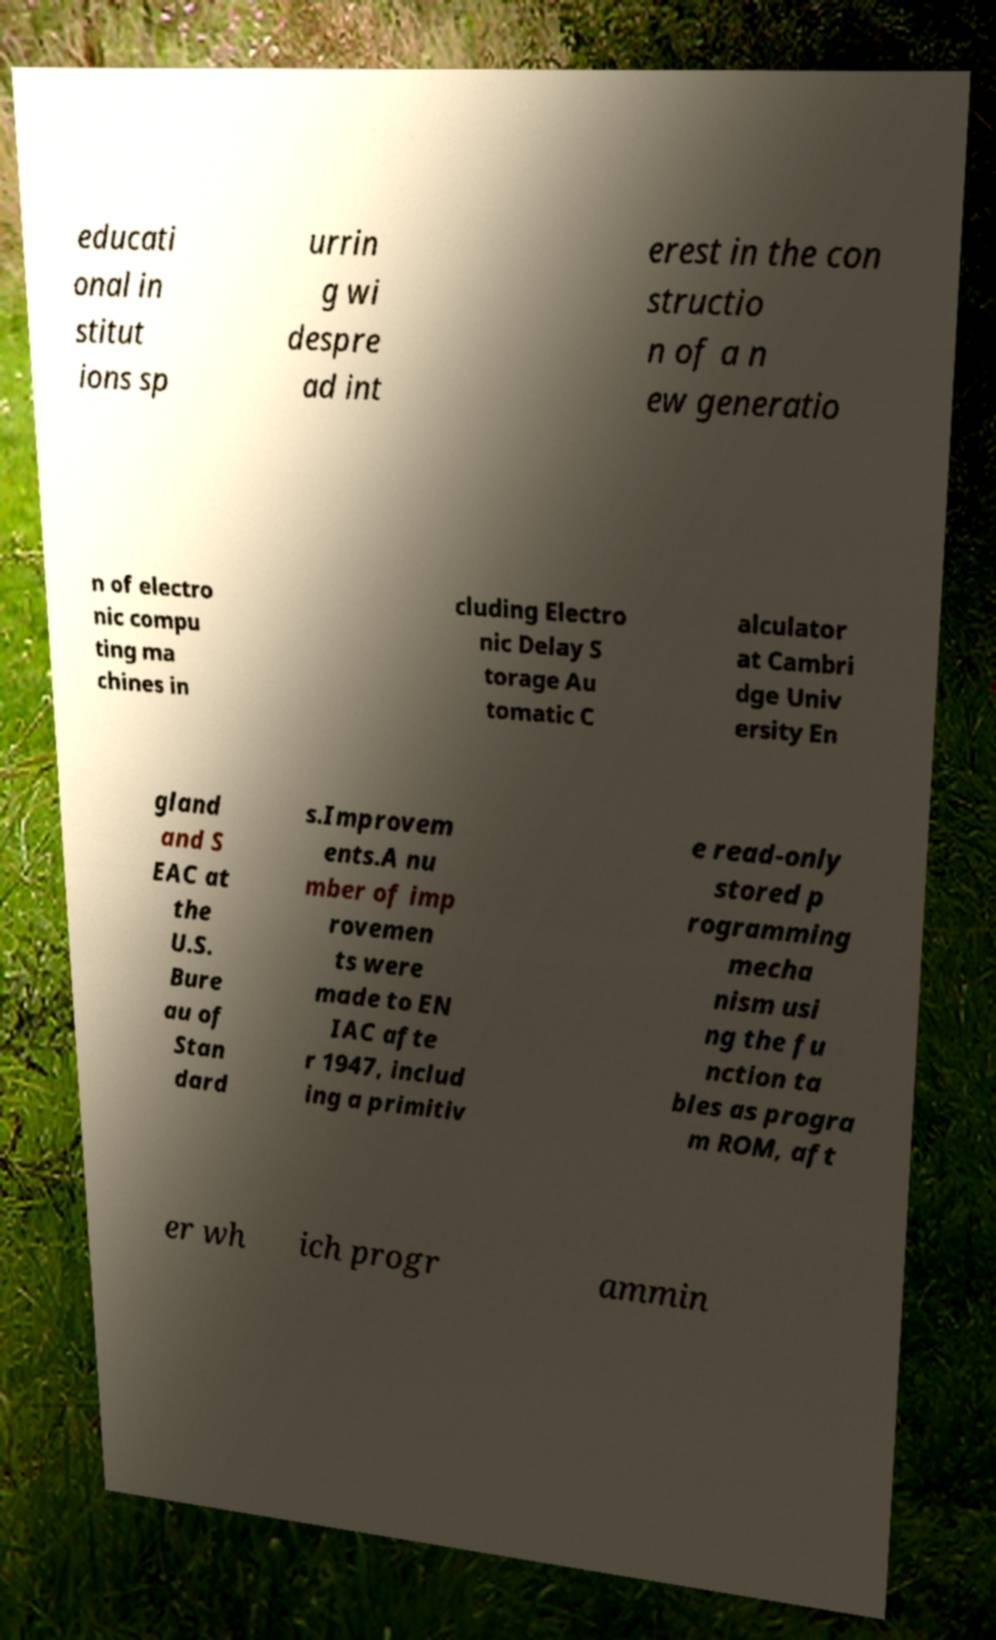Could you assist in decoding the text presented in this image and type it out clearly? educati onal in stitut ions sp urrin g wi despre ad int erest in the con structio n of a n ew generatio n of electro nic compu ting ma chines in cluding Electro nic Delay S torage Au tomatic C alculator at Cambri dge Univ ersity En gland and S EAC at the U.S. Bure au of Stan dard s.Improvem ents.A nu mber of imp rovemen ts were made to EN IAC afte r 1947, includ ing a primitiv e read-only stored p rogramming mecha nism usi ng the fu nction ta bles as progra m ROM, aft er wh ich progr ammin 